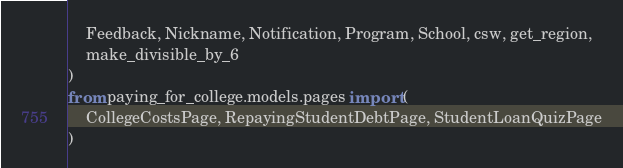<code> <loc_0><loc_0><loc_500><loc_500><_Python_>    Feedback, Nickname, Notification, Program, School, csw, get_region,
    make_divisible_by_6
)
from paying_for_college.models.pages import (
    CollegeCostsPage, RepayingStudentDebtPage, StudentLoanQuizPage
)
</code> 